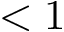<formula> <loc_0><loc_0><loc_500><loc_500>< 1</formula> 